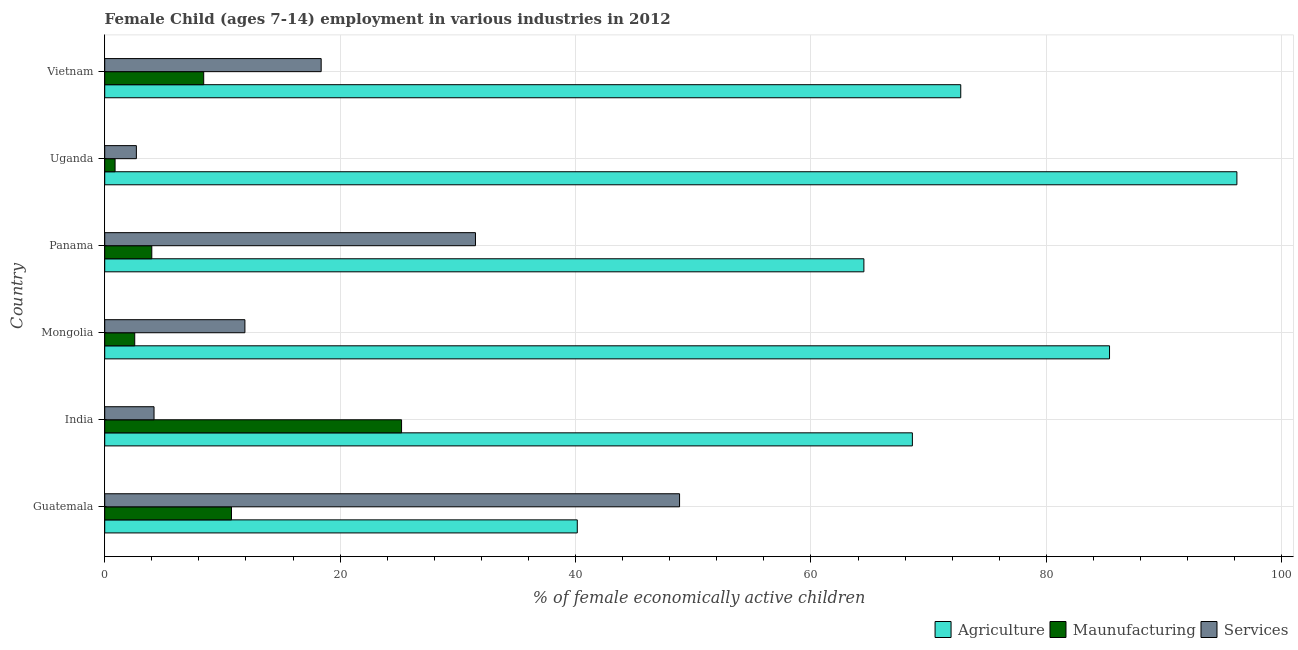How many different coloured bars are there?
Ensure brevity in your answer.  3. How many bars are there on the 1st tick from the top?
Give a very brief answer. 3. What is the label of the 2nd group of bars from the top?
Provide a short and direct response. Uganda. What is the percentage of economically active children in manufacturing in India?
Keep it short and to the point. 25.22. Across all countries, what is the maximum percentage of economically active children in services?
Keep it short and to the point. 48.84. Across all countries, what is the minimum percentage of economically active children in services?
Provide a succinct answer. 2.69. In which country was the percentage of economically active children in agriculture maximum?
Make the answer very short. Uganda. In which country was the percentage of economically active children in services minimum?
Provide a short and direct response. Uganda. What is the total percentage of economically active children in manufacturing in the graph?
Provide a short and direct response. 51.83. What is the difference between the percentage of economically active children in services in Mongolia and that in Uganda?
Your response must be concise. 9.22. What is the difference between the percentage of economically active children in agriculture in Guatemala and the percentage of economically active children in manufacturing in Panama?
Your answer should be compact. 36.15. What is the average percentage of economically active children in agriculture per country?
Provide a succinct answer. 71.26. What is the difference between the percentage of economically active children in services and percentage of economically active children in manufacturing in Guatemala?
Make the answer very short. 38.07. What is the ratio of the percentage of economically active children in agriculture in Mongolia to that in Uganda?
Give a very brief answer. 0.89. Is the difference between the percentage of economically active children in services in Mongolia and Panama greater than the difference between the percentage of economically active children in manufacturing in Mongolia and Panama?
Offer a very short reply. No. What is the difference between the highest and the second highest percentage of economically active children in agriculture?
Offer a very short reply. 10.82. What is the difference between the highest and the lowest percentage of economically active children in manufacturing?
Offer a very short reply. 24.34. In how many countries, is the percentage of economically active children in agriculture greater than the average percentage of economically active children in agriculture taken over all countries?
Offer a terse response. 3. Is the sum of the percentage of economically active children in agriculture in Guatemala and Uganda greater than the maximum percentage of economically active children in manufacturing across all countries?
Ensure brevity in your answer.  Yes. What does the 3rd bar from the top in Mongolia represents?
Ensure brevity in your answer.  Agriculture. What does the 2nd bar from the bottom in Panama represents?
Your response must be concise. Maunufacturing. Are the values on the major ticks of X-axis written in scientific E-notation?
Give a very brief answer. No. Does the graph contain any zero values?
Offer a very short reply. No. Does the graph contain grids?
Your response must be concise. Yes. How many legend labels are there?
Offer a very short reply. 3. How are the legend labels stacked?
Provide a succinct answer. Horizontal. What is the title of the graph?
Provide a succinct answer. Female Child (ages 7-14) employment in various industries in 2012. What is the label or title of the X-axis?
Keep it short and to the point. % of female economically active children. What is the label or title of the Y-axis?
Ensure brevity in your answer.  Country. What is the % of female economically active children in Agriculture in Guatemala?
Offer a terse response. 40.15. What is the % of female economically active children in Maunufacturing in Guatemala?
Ensure brevity in your answer.  10.77. What is the % of female economically active children of Services in Guatemala?
Your answer should be compact. 48.84. What is the % of female economically active children in Agriculture in India?
Your answer should be compact. 68.62. What is the % of female economically active children of Maunufacturing in India?
Offer a very short reply. 25.22. What is the % of female economically active children in Services in India?
Ensure brevity in your answer.  4.19. What is the % of female economically active children of Agriculture in Mongolia?
Offer a terse response. 85.37. What is the % of female economically active children of Maunufacturing in Mongolia?
Keep it short and to the point. 2.55. What is the % of female economically active children in Services in Mongolia?
Make the answer very short. 11.91. What is the % of female economically active children of Agriculture in Panama?
Provide a succinct answer. 64.5. What is the % of female economically active children of Services in Panama?
Provide a short and direct response. 31.5. What is the % of female economically active children in Agriculture in Uganda?
Provide a short and direct response. 96.19. What is the % of female economically active children in Services in Uganda?
Ensure brevity in your answer.  2.69. What is the % of female economically active children of Agriculture in Vietnam?
Your answer should be compact. 72.73. What is the % of female economically active children in Maunufacturing in Vietnam?
Your response must be concise. 8.41. What is the % of female economically active children in Services in Vietnam?
Offer a very short reply. 18.39. Across all countries, what is the maximum % of female economically active children of Agriculture?
Make the answer very short. 96.19. Across all countries, what is the maximum % of female economically active children in Maunufacturing?
Offer a very short reply. 25.22. Across all countries, what is the maximum % of female economically active children of Services?
Offer a very short reply. 48.84. Across all countries, what is the minimum % of female economically active children of Agriculture?
Make the answer very short. 40.15. Across all countries, what is the minimum % of female economically active children of Maunufacturing?
Offer a very short reply. 0.88. Across all countries, what is the minimum % of female economically active children in Services?
Your answer should be very brief. 2.69. What is the total % of female economically active children in Agriculture in the graph?
Your response must be concise. 427.56. What is the total % of female economically active children in Maunufacturing in the graph?
Offer a very short reply. 51.83. What is the total % of female economically active children in Services in the graph?
Provide a succinct answer. 117.52. What is the difference between the % of female economically active children of Agriculture in Guatemala and that in India?
Offer a terse response. -28.47. What is the difference between the % of female economically active children of Maunufacturing in Guatemala and that in India?
Offer a very short reply. -14.45. What is the difference between the % of female economically active children of Services in Guatemala and that in India?
Offer a terse response. 44.65. What is the difference between the % of female economically active children in Agriculture in Guatemala and that in Mongolia?
Keep it short and to the point. -45.22. What is the difference between the % of female economically active children in Maunufacturing in Guatemala and that in Mongolia?
Give a very brief answer. 8.22. What is the difference between the % of female economically active children of Services in Guatemala and that in Mongolia?
Your answer should be very brief. 36.93. What is the difference between the % of female economically active children of Agriculture in Guatemala and that in Panama?
Your response must be concise. -24.35. What is the difference between the % of female economically active children of Maunufacturing in Guatemala and that in Panama?
Provide a succinct answer. 6.77. What is the difference between the % of female economically active children of Services in Guatemala and that in Panama?
Offer a very short reply. 17.34. What is the difference between the % of female economically active children of Agriculture in Guatemala and that in Uganda?
Offer a terse response. -56.04. What is the difference between the % of female economically active children in Maunufacturing in Guatemala and that in Uganda?
Offer a terse response. 9.89. What is the difference between the % of female economically active children of Services in Guatemala and that in Uganda?
Provide a short and direct response. 46.15. What is the difference between the % of female economically active children in Agriculture in Guatemala and that in Vietnam?
Your response must be concise. -32.58. What is the difference between the % of female economically active children in Maunufacturing in Guatemala and that in Vietnam?
Offer a very short reply. 2.36. What is the difference between the % of female economically active children in Services in Guatemala and that in Vietnam?
Ensure brevity in your answer.  30.45. What is the difference between the % of female economically active children of Agriculture in India and that in Mongolia?
Your answer should be very brief. -16.75. What is the difference between the % of female economically active children of Maunufacturing in India and that in Mongolia?
Keep it short and to the point. 22.67. What is the difference between the % of female economically active children of Services in India and that in Mongolia?
Your answer should be very brief. -7.72. What is the difference between the % of female economically active children of Agriculture in India and that in Panama?
Give a very brief answer. 4.12. What is the difference between the % of female economically active children of Maunufacturing in India and that in Panama?
Make the answer very short. 21.22. What is the difference between the % of female economically active children in Services in India and that in Panama?
Give a very brief answer. -27.31. What is the difference between the % of female economically active children of Agriculture in India and that in Uganda?
Keep it short and to the point. -27.57. What is the difference between the % of female economically active children in Maunufacturing in India and that in Uganda?
Offer a terse response. 24.34. What is the difference between the % of female economically active children of Services in India and that in Uganda?
Your answer should be very brief. 1.5. What is the difference between the % of female economically active children of Agriculture in India and that in Vietnam?
Keep it short and to the point. -4.11. What is the difference between the % of female economically active children of Maunufacturing in India and that in Vietnam?
Offer a terse response. 16.81. What is the difference between the % of female economically active children of Services in India and that in Vietnam?
Your answer should be compact. -14.2. What is the difference between the % of female economically active children in Agriculture in Mongolia and that in Panama?
Make the answer very short. 20.87. What is the difference between the % of female economically active children in Maunufacturing in Mongolia and that in Panama?
Your answer should be very brief. -1.45. What is the difference between the % of female economically active children in Services in Mongolia and that in Panama?
Ensure brevity in your answer.  -19.59. What is the difference between the % of female economically active children in Agriculture in Mongolia and that in Uganda?
Ensure brevity in your answer.  -10.82. What is the difference between the % of female economically active children of Maunufacturing in Mongolia and that in Uganda?
Offer a very short reply. 1.67. What is the difference between the % of female economically active children of Services in Mongolia and that in Uganda?
Your answer should be compact. 9.22. What is the difference between the % of female economically active children of Agriculture in Mongolia and that in Vietnam?
Your answer should be compact. 12.64. What is the difference between the % of female economically active children of Maunufacturing in Mongolia and that in Vietnam?
Your answer should be compact. -5.86. What is the difference between the % of female economically active children of Services in Mongolia and that in Vietnam?
Your answer should be very brief. -6.48. What is the difference between the % of female economically active children of Agriculture in Panama and that in Uganda?
Provide a short and direct response. -31.69. What is the difference between the % of female economically active children of Maunufacturing in Panama and that in Uganda?
Your answer should be compact. 3.12. What is the difference between the % of female economically active children of Services in Panama and that in Uganda?
Ensure brevity in your answer.  28.81. What is the difference between the % of female economically active children in Agriculture in Panama and that in Vietnam?
Keep it short and to the point. -8.23. What is the difference between the % of female economically active children in Maunufacturing in Panama and that in Vietnam?
Make the answer very short. -4.41. What is the difference between the % of female economically active children of Services in Panama and that in Vietnam?
Keep it short and to the point. 13.11. What is the difference between the % of female economically active children in Agriculture in Uganda and that in Vietnam?
Your answer should be compact. 23.46. What is the difference between the % of female economically active children in Maunufacturing in Uganda and that in Vietnam?
Your answer should be compact. -7.53. What is the difference between the % of female economically active children in Services in Uganda and that in Vietnam?
Keep it short and to the point. -15.7. What is the difference between the % of female economically active children of Agriculture in Guatemala and the % of female economically active children of Maunufacturing in India?
Offer a terse response. 14.93. What is the difference between the % of female economically active children of Agriculture in Guatemala and the % of female economically active children of Services in India?
Provide a short and direct response. 35.96. What is the difference between the % of female economically active children of Maunufacturing in Guatemala and the % of female economically active children of Services in India?
Offer a terse response. 6.58. What is the difference between the % of female economically active children in Agriculture in Guatemala and the % of female economically active children in Maunufacturing in Mongolia?
Make the answer very short. 37.6. What is the difference between the % of female economically active children in Agriculture in Guatemala and the % of female economically active children in Services in Mongolia?
Make the answer very short. 28.24. What is the difference between the % of female economically active children of Maunufacturing in Guatemala and the % of female economically active children of Services in Mongolia?
Your answer should be very brief. -1.14. What is the difference between the % of female economically active children of Agriculture in Guatemala and the % of female economically active children of Maunufacturing in Panama?
Offer a terse response. 36.15. What is the difference between the % of female economically active children in Agriculture in Guatemala and the % of female economically active children in Services in Panama?
Provide a short and direct response. 8.65. What is the difference between the % of female economically active children of Maunufacturing in Guatemala and the % of female economically active children of Services in Panama?
Ensure brevity in your answer.  -20.73. What is the difference between the % of female economically active children of Agriculture in Guatemala and the % of female economically active children of Maunufacturing in Uganda?
Ensure brevity in your answer.  39.27. What is the difference between the % of female economically active children in Agriculture in Guatemala and the % of female economically active children in Services in Uganda?
Ensure brevity in your answer.  37.46. What is the difference between the % of female economically active children in Maunufacturing in Guatemala and the % of female economically active children in Services in Uganda?
Make the answer very short. 8.08. What is the difference between the % of female economically active children in Agriculture in Guatemala and the % of female economically active children in Maunufacturing in Vietnam?
Your response must be concise. 31.74. What is the difference between the % of female economically active children of Agriculture in Guatemala and the % of female economically active children of Services in Vietnam?
Ensure brevity in your answer.  21.76. What is the difference between the % of female economically active children of Maunufacturing in Guatemala and the % of female economically active children of Services in Vietnam?
Offer a terse response. -7.62. What is the difference between the % of female economically active children of Agriculture in India and the % of female economically active children of Maunufacturing in Mongolia?
Your response must be concise. 66.07. What is the difference between the % of female economically active children in Agriculture in India and the % of female economically active children in Services in Mongolia?
Offer a terse response. 56.71. What is the difference between the % of female economically active children of Maunufacturing in India and the % of female economically active children of Services in Mongolia?
Your answer should be compact. 13.31. What is the difference between the % of female economically active children in Agriculture in India and the % of female economically active children in Maunufacturing in Panama?
Your answer should be compact. 64.62. What is the difference between the % of female economically active children in Agriculture in India and the % of female economically active children in Services in Panama?
Your response must be concise. 37.12. What is the difference between the % of female economically active children of Maunufacturing in India and the % of female economically active children of Services in Panama?
Provide a short and direct response. -6.28. What is the difference between the % of female economically active children in Agriculture in India and the % of female economically active children in Maunufacturing in Uganda?
Your response must be concise. 67.74. What is the difference between the % of female economically active children of Agriculture in India and the % of female economically active children of Services in Uganda?
Offer a very short reply. 65.93. What is the difference between the % of female economically active children in Maunufacturing in India and the % of female economically active children in Services in Uganda?
Your answer should be very brief. 22.53. What is the difference between the % of female economically active children in Agriculture in India and the % of female economically active children in Maunufacturing in Vietnam?
Your answer should be very brief. 60.21. What is the difference between the % of female economically active children of Agriculture in India and the % of female economically active children of Services in Vietnam?
Offer a very short reply. 50.23. What is the difference between the % of female economically active children in Maunufacturing in India and the % of female economically active children in Services in Vietnam?
Offer a terse response. 6.83. What is the difference between the % of female economically active children of Agriculture in Mongolia and the % of female economically active children of Maunufacturing in Panama?
Keep it short and to the point. 81.37. What is the difference between the % of female economically active children in Agriculture in Mongolia and the % of female economically active children in Services in Panama?
Give a very brief answer. 53.87. What is the difference between the % of female economically active children of Maunufacturing in Mongolia and the % of female economically active children of Services in Panama?
Make the answer very short. -28.95. What is the difference between the % of female economically active children of Agriculture in Mongolia and the % of female economically active children of Maunufacturing in Uganda?
Provide a succinct answer. 84.49. What is the difference between the % of female economically active children in Agriculture in Mongolia and the % of female economically active children in Services in Uganda?
Provide a succinct answer. 82.68. What is the difference between the % of female economically active children in Maunufacturing in Mongolia and the % of female economically active children in Services in Uganda?
Provide a succinct answer. -0.14. What is the difference between the % of female economically active children of Agriculture in Mongolia and the % of female economically active children of Maunufacturing in Vietnam?
Offer a very short reply. 76.96. What is the difference between the % of female economically active children of Agriculture in Mongolia and the % of female economically active children of Services in Vietnam?
Ensure brevity in your answer.  66.98. What is the difference between the % of female economically active children of Maunufacturing in Mongolia and the % of female economically active children of Services in Vietnam?
Make the answer very short. -15.84. What is the difference between the % of female economically active children in Agriculture in Panama and the % of female economically active children in Maunufacturing in Uganda?
Offer a very short reply. 63.62. What is the difference between the % of female economically active children of Agriculture in Panama and the % of female economically active children of Services in Uganda?
Provide a succinct answer. 61.81. What is the difference between the % of female economically active children of Maunufacturing in Panama and the % of female economically active children of Services in Uganda?
Your answer should be very brief. 1.31. What is the difference between the % of female economically active children of Agriculture in Panama and the % of female economically active children of Maunufacturing in Vietnam?
Offer a terse response. 56.09. What is the difference between the % of female economically active children of Agriculture in Panama and the % of female economically active children of Services in Vietnam?
Provide a short and direct response. 46.11. What is the difference between the % of female economically active children in Maunufacturing in Panama and the % of female economically active children in Services in Vietnam?
Ensure brevity in your answer.  -14.39. What is the difference between the % of female economically active children in Agriculture in Uganda and the % of female economically active children in Maunufacturing in Vietnam?
Offer a terse response. 87.78. What is the difference between the % of female economically active children in Agriculture in Uganda and the % of female economically active children in Services in Vietnam?
Make the answer very short. 77.8. What is the difference between the % of female economically active children of Maunufacturing in Uganda and the % of female economically active children of Services in Vietnam?
Offer a very short reply. -17.51. What is the average % of female economically active children in Agriculture per country?
Provide a succinct answer. 71.26. What is the average % of female economically active children in Maunufacturing per country?
Your answer should be very brief. 8.64. What is the average % of female economically active children in Services per country?
Offer a terse response. 19.59. What is the difference between the % of female economically active children of Agriculture and % of female economically active children of Maunufacturing in Guatemala?
Your answer should be very brief. 29.38. What is the difference between the % of female economically active children of Agriculture and % of female economically active children of Services in Guatemala?
Your answer should be very brief. -8.69. What is the difference between the % of female economically active children of Maunufacturing and % of female economically active children of Services in Guatemala?
Your response must be concise. -38.07. What is the difference between the % of female economically active children of Agriculture and % of female economically active children of Maunufacturing in India?
Keep it short and to the point. 43.4. What is the difference between the % of female economically active children of Agriculture and % of female economically active children of Services in India?
Provide a succinct answer. 64.43. What is the difference between the % of female economically active children in Maunufacturing and % of female economically active children in Services in India?
Give a very brief answer. 21.03. What is the difference between the % of female economically active children in Agriculture and % of female economically active children in Maunufacturing in Mongolia?
Make the answer very short. 82.82. What is the difference between the % of female economically active children in Agriculture and % of female economically active children in Services in Mongolia?
Provide a short and direct response. 73.46. What is the difference between the % of female economically active children in Maunufacturing and % of female economically active children in Services in Mongolia?
Make the answer very short. -9.36. What is the difference between the % of female economically active children of Agriculture and % of female economically active children of Maunufacturing in Panama?
Keep it short and to the point. 60.5. What is the difference between the % of female economically active children in Agriculture and % of female economically active children in Services in Panama?
Your answer should be compact. 33. What is the difference between the % of female economically active children in Maunufacturing and % of female economically active children in Services in Panama?
Your response must be concise. -27.5. What is the difference between the % of female economically active children in Agriculture and % of female economically active children in Maunufacturing in Uganda?
Provide a short and direct response. 95.31. What is the difference between the % of female economically active children of Agriculture and % of female economically active children of Services in Uganda?
Offer a very short reply. 93.5. What is the difference between the % of female economically active children in Maunufacturing and % of female economically active children in Services in Uganda?
Offer a very short reply. -1.81. What is the difference between the % of female economically active children of Agriculture and % of female economically active children of Maunufacturing in Vietnam?
Keep it short and to the point. 64.32. What is the difference between the % of female economically active children in Agriculture and % of female economically active children in Services in Vietnam?
Provide a succinct answer. 54.34. What is the difference between the % of female economically active children of Maunufacturing and % of female economically active children of Services in Vietnam?
Provide a succinct answer. -9.98. What is the ratio of the % of female economically active children in Agriculture in Guatemala to that in India?
Offer a very short reply. 0.59. What is the ratio of the % of female economically active children of Maunufacturing in Guatemala to that in India?
Your answer should be very brief. 0.43. What is the ratio of the % of female economically active children in Services in Guatemala to that in India?
Provide a short and direct response. 11.66. What is the ratio of the % of female economically active children in Agriculture in Guatemala to that in Mongolia?
Offer a terse response. 0.47. What is the ratio of the % of female economically active children in Maunufacturing in Guatemala to that in Mongolia?
Give a very brief answer. 4.22. What is the ratio of the % of female economically active children of Services in Guatemala to that in Mongolia?
Offer a very short reply. 4.1. What is the ratio of the % of female economically active children of Agriculture in Guatemala to that in Panama?
Ensure brevity in your answer.  0.62. What is the ratio of the % of female economically active children of Maunufacturing in Guatemala to that in Panama?
Provide a short and direct response. 2.69. What is the ratio of the % of female economically active children of Services in Guatemala to that in Panama?
Offer a very short reply. 1.55. What is the ratio of the % of female economically active children of Agriculture in Guatemala to that in Uganda?
Provide a short and direct response. 0.42. What is the ratio of the % of female economically active children in Maunufacturing in Guatemala to that in Uganda?
Offer a terse response. 12.24. What is the ratio of the % of female economically active children of Services in Guatemala to that in Uganda?
Your answer should be very brief. 18.16. What is the ratio of the % of female economically active children of Agriculture in Guatemala to that in Vietnam?
Provide a short and direct response. 0.55. What is the ratio of the % of female economically active children in Maunufacturing in Guatemala to that in Vietnam?
Your answer should be very brief. 1.28. What is the ratio of the % of female economically active children in Services in Guatemala to that in Vietnam?
Give a very brief answer. 2.66. What is the ratio of the % of female economically active children in Agriculture in India to that in Mongolia?
Make the answer very short. 0.8. What is the ratio of the % of female economically active children of Maunufacturing in India to that in Mongolia?
Offer a very short reply. 9.89. What is the ratio of the % of female economically active children of Services in India to that in Mongolia?
Your answer should be very brief. 0.35. What is the ratio of the % of female economically active children in Agriculture in India to that in Panama?
Provide a succinct answer. 1.06. What is the ratio of the % of female economically active children of Maunufacturing in India to that in Panama?
Your answer should be compact. 6.3. What is the ratio of the % of female economically active children of Services in India to that in Panama?
Your answer should be very brief. 0.13. What is the ratio of the % of female economically active children in Agriculture in India to that in Uganda?
Provide a succinct answer. 0.71. What is the ratio of the % of female economically active children in Maunufacturing in India to that in Uganda?
Provide a succinct answer. 28.66. What is the ratio of the % of female economically active children in Services in India to that in Uganda?
Keep it short and to the point. 1.56. What is the ratio of the % of female economically active children in Agriculture in India to that in Vietnam?
Your response must be concise. 0.94. What is the ratio of the % of female economically active children in Maunufacturing in India to that in Vietnam?
Provide a short and direct response. 3. What is the ratio of the % of female economically active children in Services in India to that in Vietnam?
Keep it short and to the point. 0.23. What is the ratio of the % of female economically active children of Agriculture in Mongolia to that in Panama?
Ensure brevity in your answer.  1.32. What is the ratio of the % of female economically active children of Maunufacturing in Mongolia to that in Panama?
Keep it short and to the point. 0.64. What is the ratio of the % of female economically active children in Services in Mongolia to that in Panama?
Provide a succinct answer. 0.38. What is the ratio of the % of female economically active children in Agriculture in Mongolia to that in Uganda?
Offer a terse response. 0.89. What is the ratio of the % of female economically active children in Maunufacturing in Mongolia to that in Uganda?
Make the answer very short. 2.9. What is the ratio of the % of female economically active children of Services in Mongolia to that in Uganda?
Ensure brevity in your answer.  4.43. What is the ratio of the % of female economically active children in Agriculture in Mongolia to that in Vietnam?
Offer a terse response. 1.17. What is the ratio of the % of female economically active children of Maunufacturing in Mongolia to that in Vietnam?
Ensure brevity in your answer.  0.3. What is the ratio of the % of female economically active children in Services in Mongolia to that in Vietnam?
Make the answer very short. 0.65. What is the ratio of the % of female economically active children in Agriculture in Panama to that in Uganda?
Provide a short and direct response. 0.67. What is the ratio of the % of female economically active children of Maunufacturing in Panama to that in Uganda?
Keep it short and to the point. 4.55. What is the ratio of the % of female economically active children in Services in Panama to that in Uganda?
Offer a very short reply. 11.71. What is the ratio of the % of female economically active children of Agriculture in Panama to that in Vietnam?
Offer a terse response. 0.89. What is the ratio of the % of female economically active children in Maunufacturing in Panama to that in Vietnam?
Provide a succinct answer. 0.48. What is the ratio of the % of female economically active children of Services in Panama to that in Vietnam?
Provide a short and direct response. 1.71. What is the ratio of the % of female economically active children in Agriculture in Uganda to that in Vietnam?
Offer a very short reply. 1.32. What is the ratio of the % of female economically active children in Maunufacturing in Uganda to that in Vietnam?
Keep it short and to the point. 0.1. What is the ratio of the % of female economically active children of Services in Uganda to that in Vietnam?
Give a very brief answer. 0.15. What is the difference between the highest and the second highest % of female economically active children of Agriculture?
Make the answer very short. 10.82. What is the difference between the highest and the second highest % of female economically active children in Maunufacturing?
Your answer should be compact. 14.45. What is the difference between the highest and the second highest % of female economically active children in Services?
Your response must be concise. 17.34. What is the difference between the highest and the lowest % of female economically active children in Agriculture?
Your response must be concise. 56.04. What is the difference between the highest and the lowest % of female economically active children of Maunufacturing?
Offer a very short reply. 24.34. What is the difference between the highest and the lowest % of female economically active children of Services?
Provide a short and direct response. 46.15. 